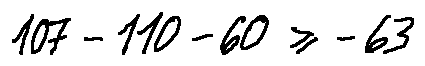Convert formula to latex. <formula><loc_0><loc_0><loc_500><loc_500>1 0 7 - 1 1 0 - 6 0 \geq - 6 3</formula> 